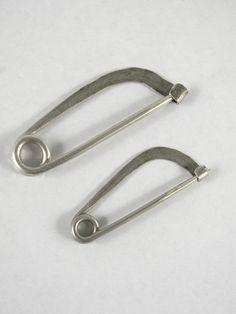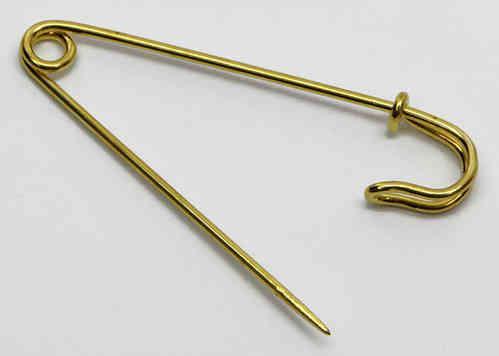The first image is the image on the left, the second image is the image on the right. Evaluate the accuracy of this statement regarding the images: "One image contains a single, open safety pin, and the other image shows two closed pins of a different style.". Is it true? Answer yes or no. Yes. The first image is the image on the left, the second image is the image on the right. Assess this claim about the two images: "The right image contains exactly two safety pins.". Correct or not? Answer yes or no. No. 